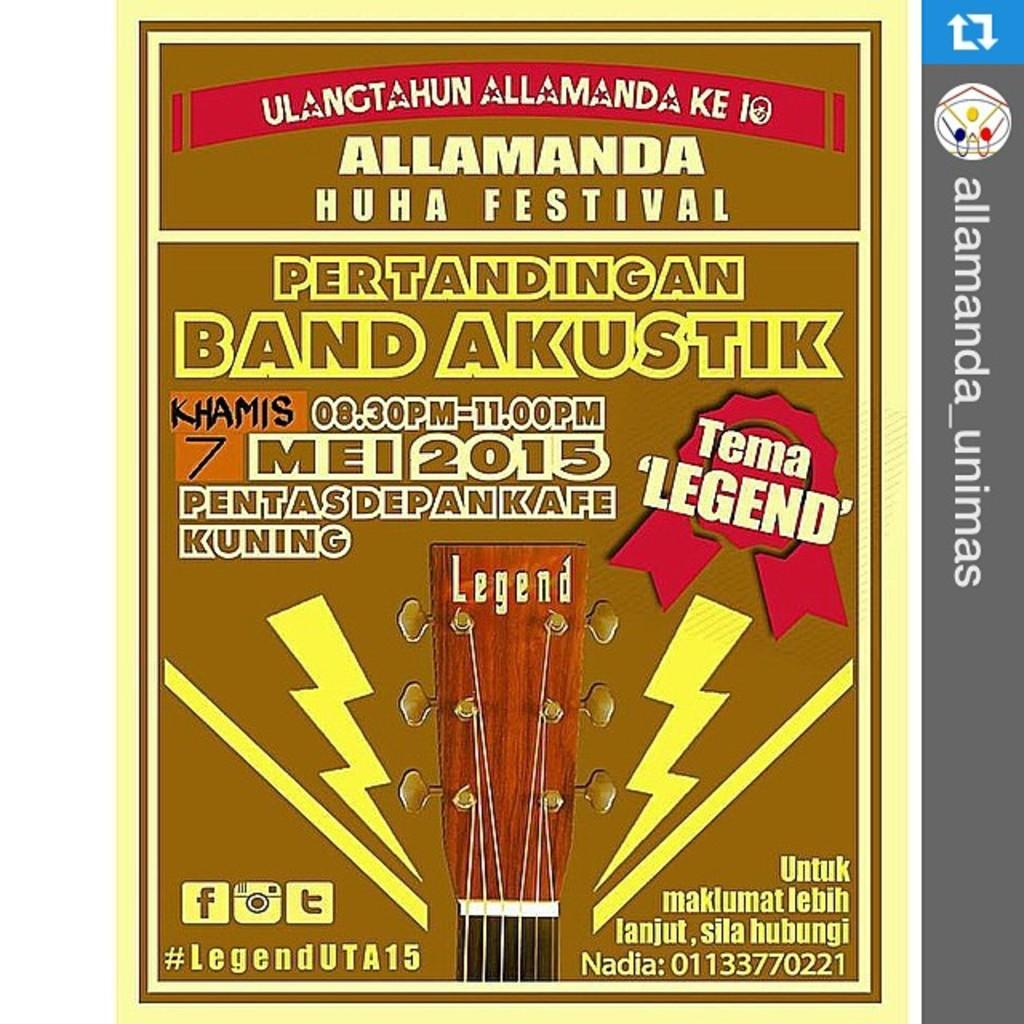<image>
Write a terse but informative summary of the picture. A brown poster that reads Allamanda Huhu Festival featuring Pertandingan Band Akustik with a guitar end displayed 